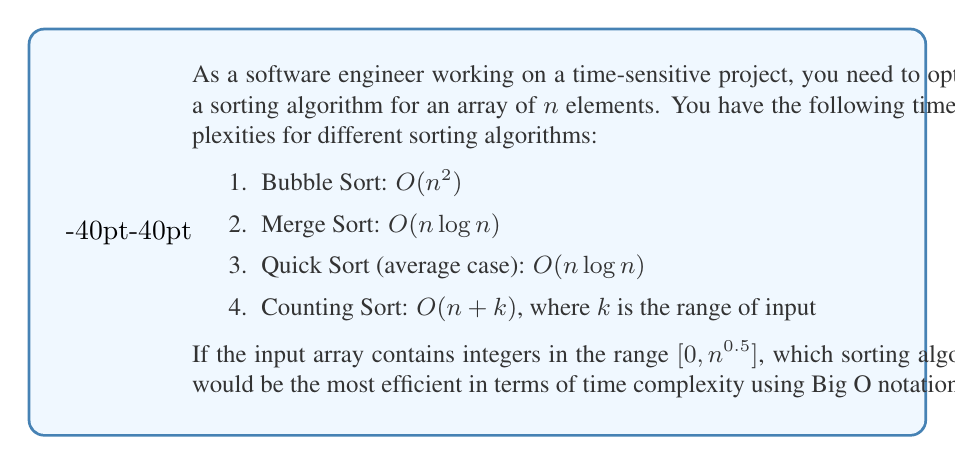Give your solution to this math problem. Let's analyze each sorting algorithm's time complexity in the context of the given input range:

1. Bubble Sort: $O(n^2)$
   This is always quadratic, regardless of the input range.

2. Merge Sort: $O(n \log n)$
   This is always $n \log n$, regardless of the input range.

3. Quick Sort (average case): $O(n \log n)$
   This is $n \log n$ on average, regardless of the input range.

4. Counting Sort: $O(n + k)$, where $k$ is the range of input
   In this case, $k = n^{0.5}$ (the upper bound of the input range)

   So, the time complexity for Counting Sort becomes:
   $O(n + n^{0.5})$

Now, let's compare $O(n + n^{0.5})$ with $O(n \log n)$:

As $n$ grows larger, $n^{0.5}$ grows slower than $\log n$. Therefore, for sufficiently large $n$, we have:

$n + n^{0.5} < n \log n$

This means that Counting Sort, with complexity $O(n + n^{0.5})$, will be more efficient than the $O(n \log n)$ algorithms for large inputs.

Furthermore, $O(n + n^{0.5})$ can be simplified to $O(n)$ because $n$ dominates $n^{0.5}$ for large $n$.

Therefore, Counting Sort with $O(n)$ complexity is the most efficient algorithm for this scenario.
Answer: $O(n)$ 